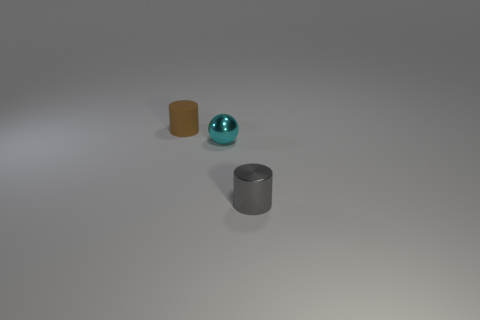What is the color of the cylinder left of the metal thing that is right of the cyan shiny object?
Offer a terse response. Brown. There is a ball that is the same size as the brown thing; what color is it?
Make the answer very short. Cyan. How many rubber objects are either large red blocks or tiny brown cylinders?
Make the answer very short. 1. How many things are behind the tiny cylinder that is to the right of the brown cylinder?
Your response must be concise. 2. How many things are tiny metallic things or tiny cylinders that are right of the small brown rubber cylinder?
Offer a terse response. 2. Are there any yellow spheres made of the same material as the tiny cyan object?
Offer a terse response. No. What number of small cylinders are to the left of the gray metallic cylinder and right of the tiny rubber object?
Ensure brevity in your answer.  0. What is the material of the cylinder that is behind the gray cylinder?
Provide a succinct answer. Rubber. What is the size of the other object that is made of the same material as the small cyan object?
Keep it short and to the point. Small. There is a matte thing; are there any tiny matte cylinders in front of it?
Provide a short and direct response. No. 